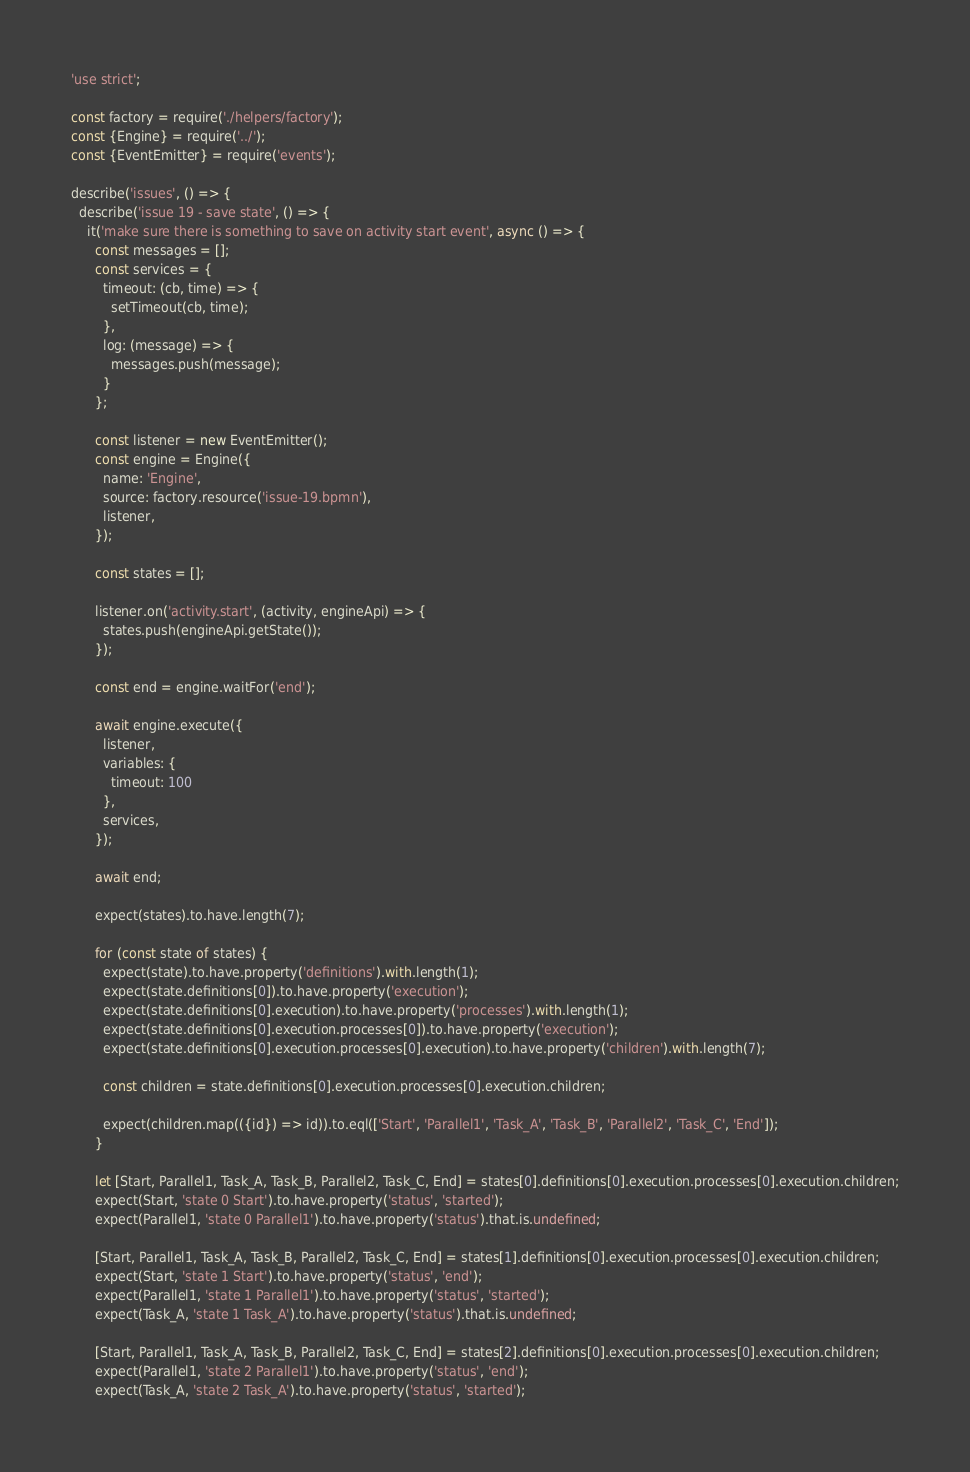<code> <loc_0><loc_0><loc_500><loc_500><_JavaScript_>'use strict';

const factory = require('./helpers/factory');
const {Engine} = require('../');
const {EventEmitter} = require('events');

describe('issues', () => {
  describe('issue 19 - save state', () => {
    it('make sure there is something to save on activity start event', async () => {
      const messages = [];
      const services = {
        timeout: (cb, time) => {
          setTimeout(cb, time);
        },
        log: (message) => {
          messages.push(message);
        }
      };

      const listener = new EventEmitter();
      const engine = Engine({
        name: 'Engine',
        source: factory.resource('issue-19.bpmn'),
        listener,
      });

      const states = [];

      listener.on('activity.start', (activity, engineApi) => {
        states.push(engineApi.getState());
      });

      const end = engine.waitFor('end');

      await engine.execute({
        listener,
        variables: {
          timeout: 100
        },
        services,
      });

      await end;

      expect(states).to.have.length(7);

      for (const state of states) {
        expect(state).to.have.property('definitions').with.length(1);
        expect(state.definitions[0]).to.have.property('execution');
        expect(state.definitions[0].execution).to.have.property('processes').with.length(1);
        expect(state.definitions[0].execution.processes[0]).to.have.property('execution');
        expect(state.definitions[0].execution.processes[0].execution).to.have.property('children').with.length(7);

        const children = state.definitions[0].execution.processes[0].execution.children;

        expect(children.map(({id}) => id)).to.eql(['Start', 'Parallel1', 'Task_A', 'Task_B', 'Parallel2', 'Task_C', 'End']);
      }

      let [Start, Parallel1, Task_A, Task_B, Parallel2, Task_C, End] = states[0].definitions[0].execution.processes[0].execution.children;
      expect(Start, 'state 0 Start').to.have.property('status', 'started');
      expect(Parallel1, 'state 0 Parallel1').to.have.property('status').that.is.undefined;

      [Start, Parallel1, Task_A, Task_B, Parallel2, Task_C, End] = states[1].definitions[0].execution.processes[0].execution.children;
      expect(Start, 'state 1 Start').to.have.property('status', 'end');
      expect(Parallel1, 'state 1 Parallel1').to.have.property('status', 'started');
      expect(Task_A, 'state 1 Task_A').to.have.property('status').that.is.undefined;

      [Start, Parallel1, Task_A, Task_B, Parallel2, Task_C, End] = states[2].definitions[0].execution.processes[0].execution.children;
      expect(Parallel1, 'state 2 Parallel1').to.have.property('status', 'end');
      expect(Task_A, 'state 2 Task_A').to.have.property('status', 'started');</code> 